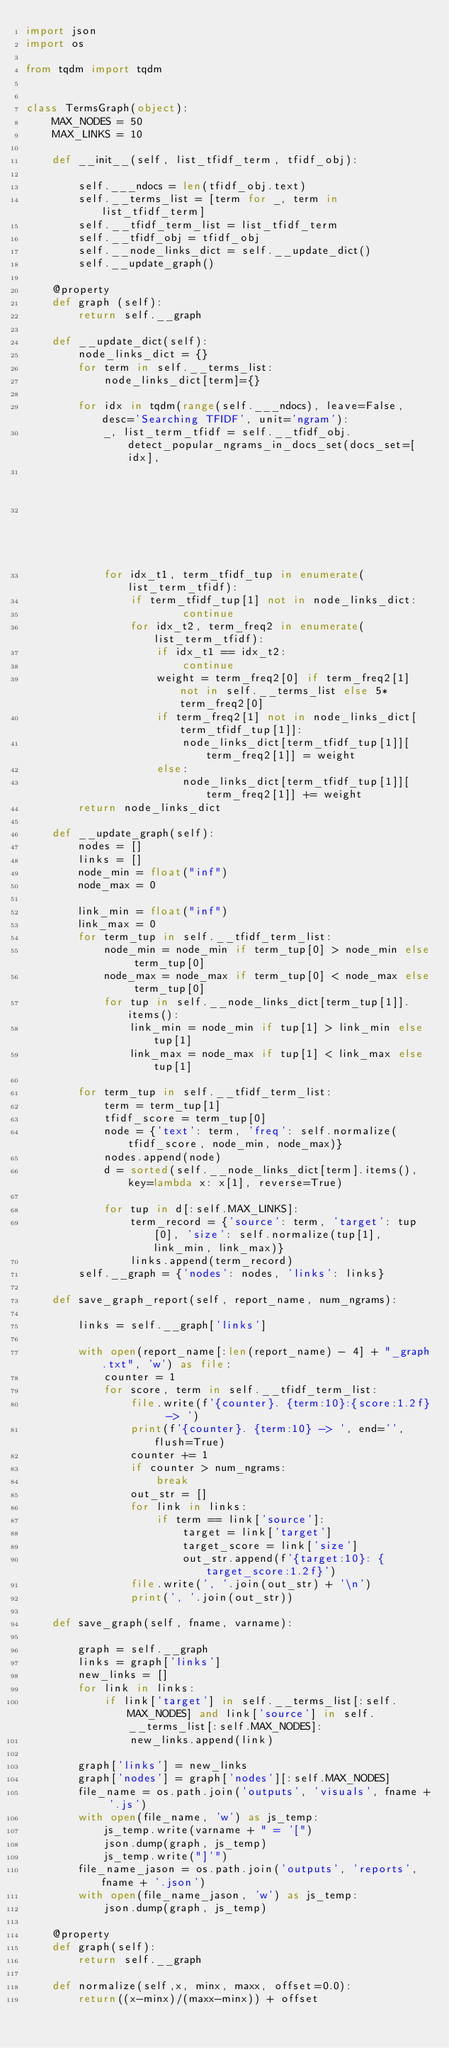Convert code to text. <code><loc_0><loc_0><loc_500><loc_500><_Python_>import json
import os

from tqdm import tqdm


class TermsGraph(object):
    MAX_NODES = 50
    MAX_LINKS = 10

    def __init__(self, list_tfidf_term, tfidf_obj):

        self.___ndocs = len(tfidf_obj.text)
        self.__terms_list = [term for _, term in list_tfidf_term]
        self.__tfidf_term_list = list_tfidf_term
        self.__tfidf_obj = tfidf_obj
        self.__node_links_dict = self.__update_dict()
        self.__update_graph()

    @property
    def graph (self):
        return self.__graph

    def __update_dict(self):
        node_links_dict = {}
        for term in self.__terms_list:
            node_links_dict[term]={}

        for idx in tqdm(range(self.___ndocs), leave=False, desc='Searching TFIDF', unit='ngram'):
            _, list_term_tfidf = self.__tfidf_obj.detect_popular_ngrams_in_docs_set(docs_set=[idx],
                                                                                    number_of_ngrams_to_return=10,
                                                                                    verbose=False)
            for idx_t1, term_tfidf_tup in enumerate(list_term_tfidf):
                if term_tfidf_tup[1] not in node_links_dict:
                        continue
                for idx_t2, term_freq2 in enumerate(list_term_tfidf):
                    if idx_t1 == idx_t2:
                        continue
                    weight = term_freq2[0] if term_freq2[1] not in self.__terms_list else 5*term_freq2[0]
                    if term_freq2[1] not in node_links_dict[term_tfidf_tup[1]]:
                        node_links_dict[term_tfidf_tup[1]][term_freq2[1]] = weight
                    else:
                        node_links_dict[term_tfidf_tup[1]][term_freq2[1]] += weight
        return node_links_dict

    def __update_graph(self):
        nodes = []
        links = []
        node_min = float("inf")
        node_max = 0

        link_min = float("inf")
        link_max = 0
        for term_tup in self.__tfidf_term_list:
            node_min = node_min if term_tup[0] > node_min else term_tup[0]
            node_max = node_max if term_tup[0] < node_max else term_tup[0]
            for tup in self.__node_links_dict[term_tup[1]].items():
                link_min = node_min if tup[1] > link_min else tup[1]
                link_max = node_max if tup[1] < link_max else tup[1]

        for term_tup in self.__tfidf_term_list:
            term = term_tup[1]
            tfidf_score = term_tup[0]
            node = {'text': term, 'freq': self.normalize(tfidf_score, node_min, node_max)}
            nodes.append(node)
            d = sorted(self.__node_links_dict[term].items(), key=lambda x: x[1], reverse=True)

            for tup in d[:self.MAX_LINKS]:
                term_record = {'source': term, 'target': tup[0], 'size': self.normalize(tup[1], link_min, link_max)}
                links.append(term_record)
        self.__graph = {'nodes': nodes, 'links': links}

    def save_graph_report(self, report_name, num_ngrams):

        links = self.__graph['links']

        with open(report_name[:len(report_name) - 4] + "_graph.txt", 'w') as file:
            counter = 1
            for score, term in self.__tfidf_term_list:
                file.write(f'{counter}. {term:10}:{score:1.2f}  -> ')
                print(f'{counter}. {term:10} -> ', end='', flush=True)
                counter += 1
                if counter > num_ngrams:
                    break
                out_str = []
                for link in links:
                    if term == link['source']:
                        target = link['target']
                        target_score = link['size']
                        out_str.append(f'{target:10}: {target_score:1.2f}')
                file.write(', '.join(out_str) + '\n')
                print(', '.join(out_str))

    def save_graph(self, fname, varname):

        graph = self.__graph
        links = graph['links']
        new_links = []
        for link in links:
            if link['target'] in self.__terms_list[:self.MAX_NODES] and link['source'] in self.__terms_list[:self.MAX_NODES]:
                new_links.append(link)

        graph['links'] = new_links
        graph['nodes'] = graph['nodes'][:self.MAX_NODES]
        file_name = os.path.join('outputs', 'visuals', fname + '.js')
        with open(file_name, 'w') as js_temp:
            js_temp.write(varname + " = '[")
            json.dump(graph, js_temp)
            js_temp.write("]'")
        file_name_jason = os.path.join('outputs', 'reports', fname + '.json')
        with open(file_name_jason, 'w') as js_temp:
            json.dump(graph, js_temp)

    @property
    def graph(self):
        return self.__graph

    def normalize(self,x, minx, maxx, offset=0.0):
        return((x-minx)/(maxx-minx)) + offset
</code> 